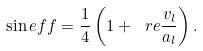Convert formula to latex. <formula><loc_0><loc_0><loc_500><loc_500>\sin e f f = \frac { 1 } { 4 } \left ( 1 + \ r e \frac { v _ { l } } { a _ { l } } \right ) .</formula> 